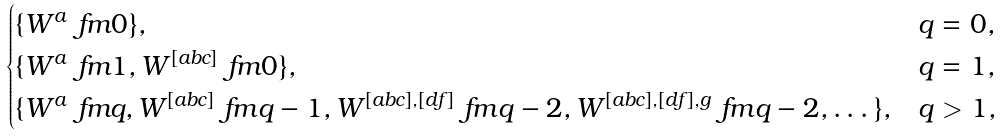Convert formula to latex. <formula><loc_0><loc_0><loc_500><loc_500>\begin{cases} \{ W ^ { a } \ f m { 0 } \} , & q = 0 , \\ \{ W ^ { a } \ f m { 1 } , W ^ { [ a b c ] } \ f m { 0 } \} , & q = 1 , \\ \{ W ^ { a } \ f m { q } , W ^ { [ a b c ] } \ f m { q - 1 } , W ^ { [ a b c ] , [ d f ] } \ f m { q - 2 } , W ^ { [ a b c ] , [ d f ] , g } \ f m { q - 2 } , \dots \} , & q > 1 , \end{cases}</formula> 